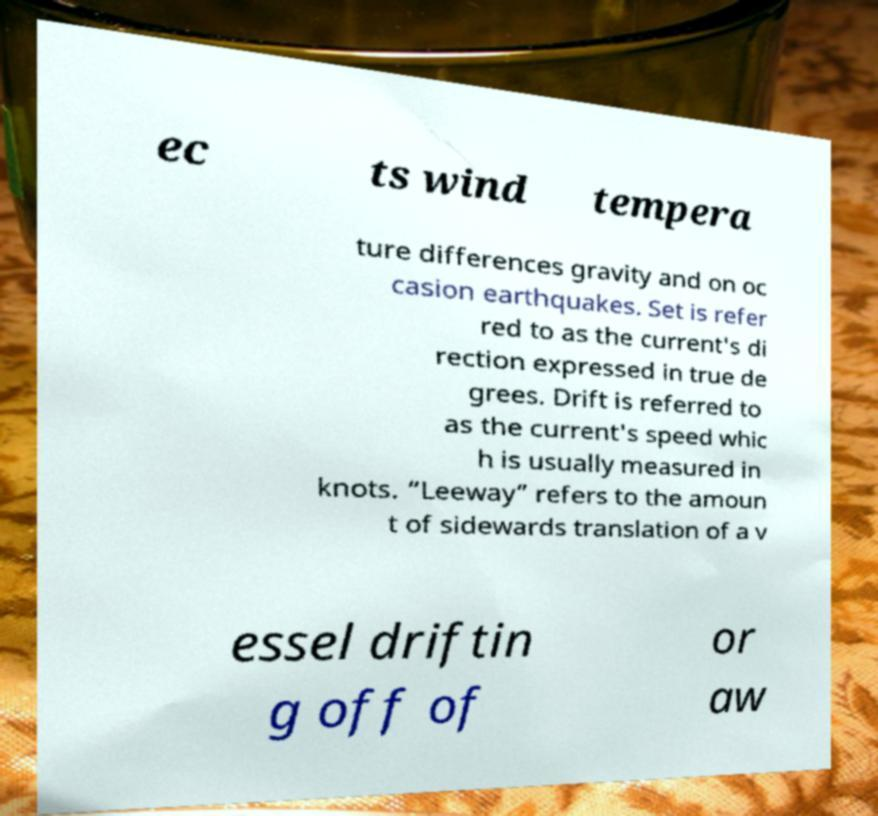For documentation purposes, I need the text within this image transcribed. Could you provide that? ec ts wind tempera ture differences gravity and on oc casion earthquakes. Set is refer red to as the current's di rection expressed in true de grees. Drift is referred to as the current's speed whic h is usually measured in knots. “Leeway” refers to the amoun t of sidewards translation of a v essel driftin g off of or aw 